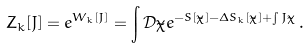<formula> <loc_0><loc_0><loc_500><loc_500>Z _ { k } [ J ] = e ^ { W _ { k } [ J ] } = \int \mathcal { D } \tilde { \chi } e ^ { - S [ \tilde { \chi } ] - \Delta S _ { k } [ \tilde { \chi } ] + \int J \tilde { \chi } } \, .</formula> 